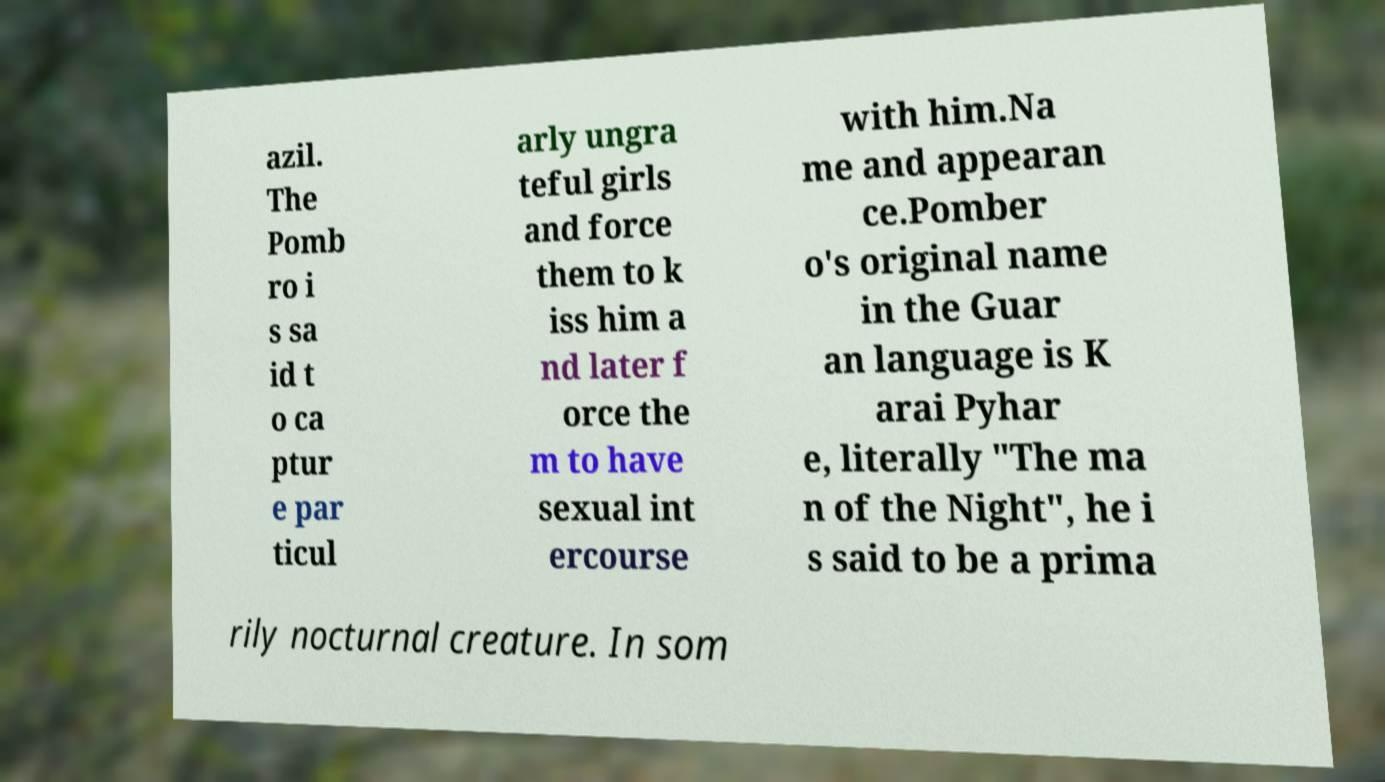Please read and relay the text visible in this image. What does it say? azil. The Pomb ro i s sa id t o ca ptur e par ticul arly ungra teful girls and force them to k iss him a nd later f orce the m to have sexual int ercourse with him.Na me and appearan ce.Pomber o's original name in the Guar an language is K arai Pyhar e, literally "The ma n of the Night", he i s said to be a prima rily nocturnal creature. In som 